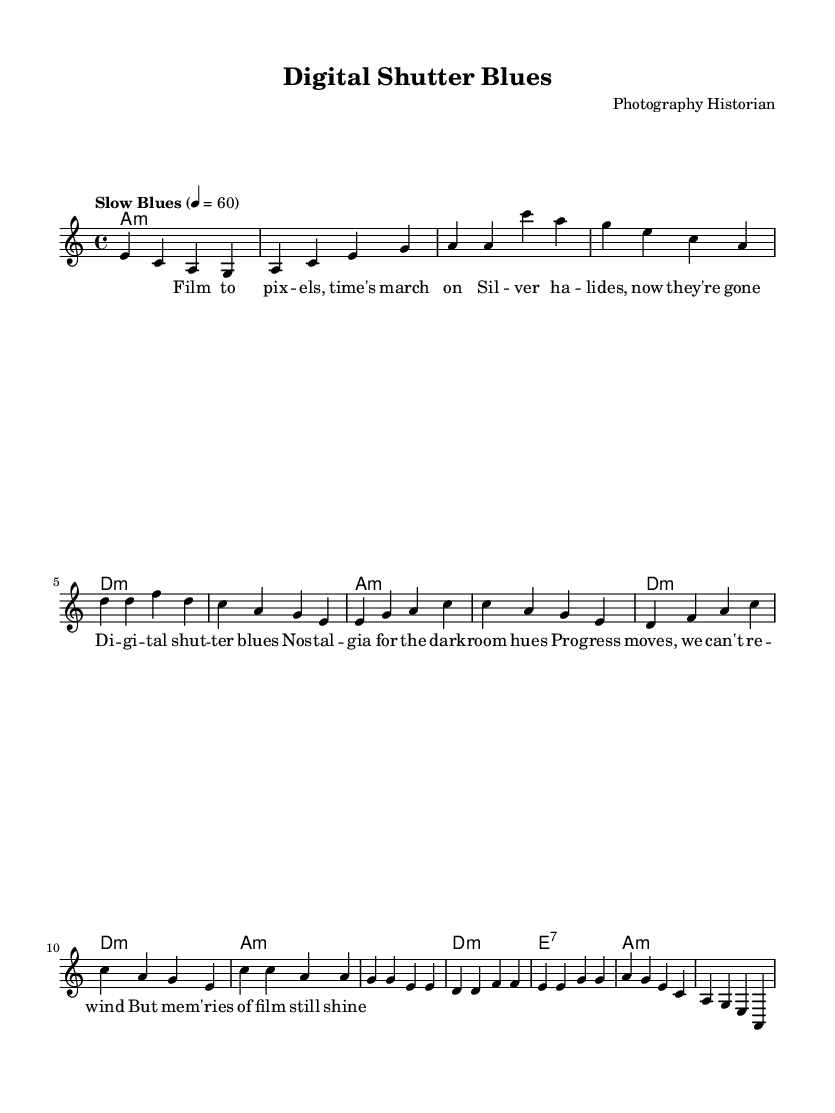What is the key signature of this music? The key signature is A minor, indicated by the absence of sharps or flats in the sheet music. This can be confirmed by observing the global section where the key is specified.
Answer: A minor What is the time signature of the piece? The time signature is 4/4, indicated in the global section of the sheet music. This means there are four beats per measure, and the quarter note gets one beat.
Answer: 4/4 What tempo marking is used for this piece? The tempo marking is "Slow Blues," which is clearly noted in the global section. It also specifies a tempo of quarter note equals 60 beats per minute.
Answer: Slow Blues How many bars are in the chorus section? The chorus consists of four measures, as observed from the melody line where it is labeled as the chorus and contains four distinct sets of notes separated by bar lines.
Answer: 4 What chord is played in the first measure? The first measure features an A minor chord, which is indicated in the harmonies part of the sheet music. Each chord name is provided above the corresponding melody notes.
Answer: A minor What is the primary theme reflected in the lyrics? The primary theme addresses the transition and nostalgia from film to digital photography, indicated in the lyrics where it mentions elements like "Film," "digital shutter," and "nostalgia." This reflects a broader commentary on technological change.
Answer: Transition and nostalgia What type of music is this piece categorized as? This piece falls under the genre of Blues, as exemplified by the slow tempo and the lyrical themes of melancholy and reflection, typical characteristics of this style.
Answer: Blues 